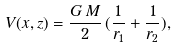Convert formula to latex. <formula><loc_0><loc_0><loc_500><loc_500>V ( x , z ) = \frac { G \, M } { 2 } \, ( \frac { 1 } { r _ { 1 } } + \frac { 1 } { r _ { 2 } } ) ,</formula> 